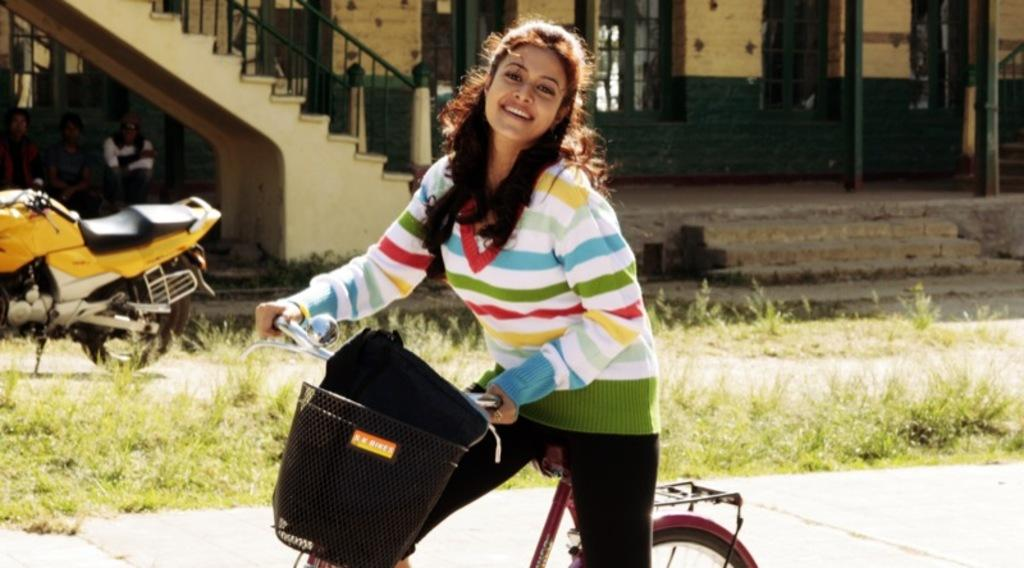Who is the main subject in the image? There is a woman in the image. What is the woman doing in the image? The woman is riding a bicycle. Can you describe the objects around the woman? There is a bike behind the woman, and there is a building with a glass window in the background of the image. Are there any other people in the image? Yes, there are people sitting on the left side of the image. What type of watch is the giant wearing in the image? There are no giants or watches present in the image. Can you tell me the name of the parent sitting on the left side of the image? There is no indication of a parent or their name in the image. 